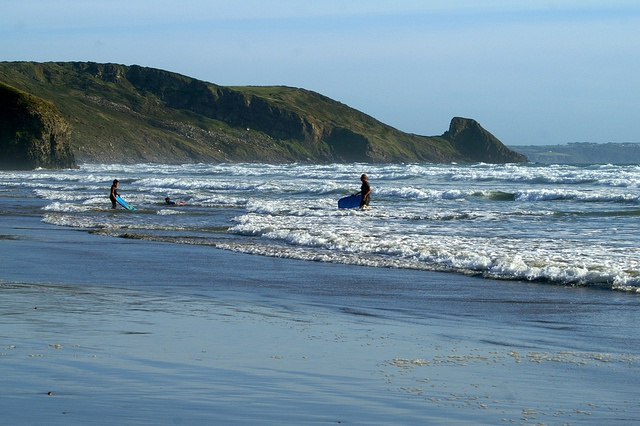Describe the objects in this image and their specific colors. I can see people in lightblue, black, gray, and maroon tones, surfboard in lightblue, navy, and gray tones, people in lightblue, black, maroon, gray, and blue tones, surfboard in lightblue and teal tones, and people in lightblue, black, gray, and darkgray tones in this image. 